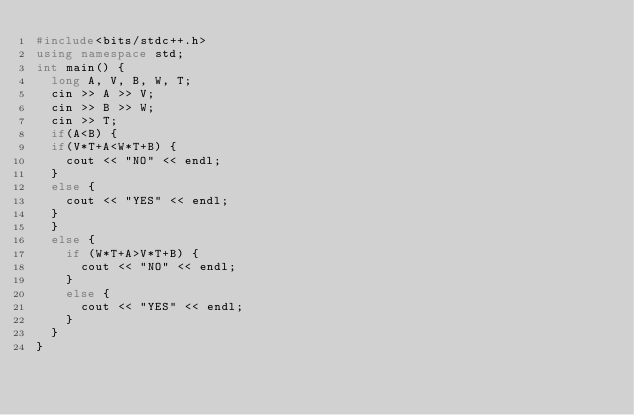<code> <loc_0><loc_0><loc_500><loc_500><_C++_>#include<bits/stdc++.h>
using namespace std;
int main() {
  long A, V, B, W, T;
  cin >> A >> V;
  cin >> B >> W;
  cin >> T;
  if(A<B) {
  if(V*T+A<W*T+B) {
    cout << "NO" << endl;
  }
  else {
    cout << "YES" << endl;
  }
  }
  else {
    if (W*T+A>V*T+B) {
      cout << "NO" << endl;
    }
    else {
      cout << "YES" << endl;
    }
  }
}
</code> 